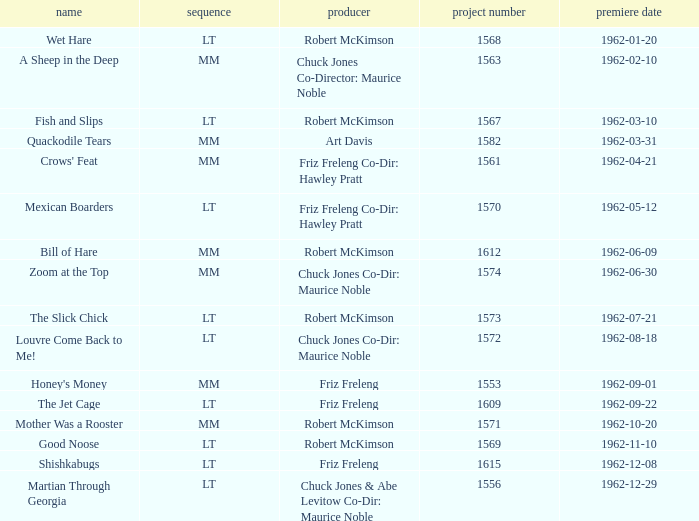What is the title of the film with production number 1553, directed by Friz Freleng? Honey's Money. 